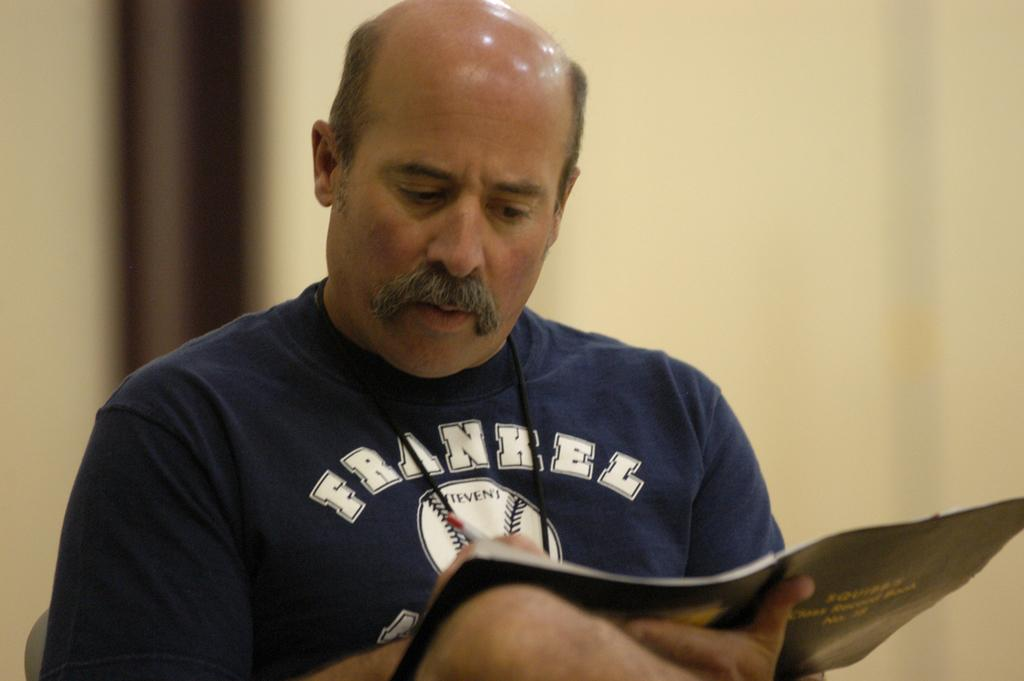<image>
Give a short and clear explanation of the subsequent image. A man with very little hair, wearing a Frankel shirt, reads a magazine. 